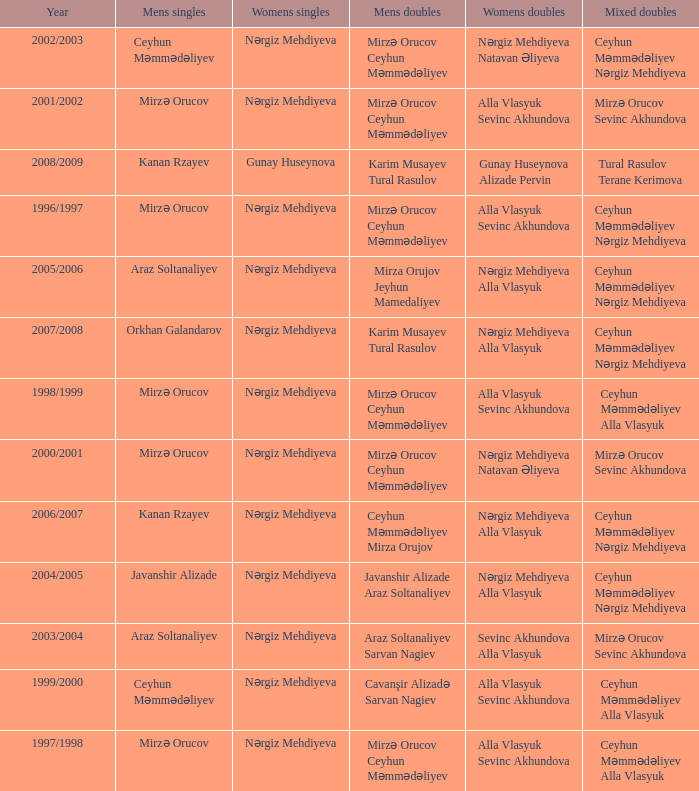Write the full table. {'header': ['Year', 'Mens singles', 'Womens singles', 'Mens doubles', 'Womens doubles', 'Mixed doubles'], 'rows': [['2002/2003', 'Ceyhun Məmmədəliyev', 'Nərgiz Mehdiyeva', 'Mirzə Orucov Ceyhun Məmmədəliyev', 'Nərgiz Mehdiyeva Natavan Əliyeva', 'Ceyhun Məmmədəliyev Nərgiz Mehdiyeva'], ['2001/2002', 'Mirzə Orucov', 'Nərgiz Mehdiyeva', 'Mirzə Orucov Ceyhun Məmmədəliyev', 'Alla Vlasyuk Sevinc Akhundova', 'Mirzə Orucov Sevinc Akhundova'], ['2008/2009', 'Kanan Rzayev', 'Gunay Huseynova', 'Karim Musayev Tural Rasulov', 'Gunay Huseynova Alizade Pervin', 'Tural Rasulov Terane Kerimova'], ['1996/1997', 'Mirzə Orucov', 'Nərgiz Mehdiyeva', 'Mirzə Orucov Ceyhun Məmmədəliyev', 'Alla Vlasyuk Sevinc Akhundova', 'Ceyhun Məmmədəliyev Nərgiz Mehdiyeva'], ['2005/2006', 'Araz Soltanaliyev', 'Nərgiz Mehdiyeva', 'Mirza Orujov Jeyhun Mamedaliyev', 'Nərgiz Mehdiyeva Alla Vlasyuk', 'Ceyhun Məmmədəliyev Nərgiz Mehdiyeva'], ['2007/2008', 'Orkhan Galandarov', 'Nərgiz Mehdiyeva', 'Karim Musayev Tural Rasulov', 'Nərgiz Mehdiyeva Alla Vlasyuk', 'Ceyhun Məmmədəliyev Nərgiz Mehdiyeva'], ['1998/1999', 'Mirzə Orucov', 'Nərgiz Mehdiyeva', 'Mirzə Orucov Ceyhun Məmmədəliyev', 'Alla Vlasyuk Sevinc Akhundova', 'Ceyhun Məmmədəliyev Alla Vlasyuk'], ['2000/2001', 'Mirzə Orucov', 'Nərgiz Mehdiyeva', 'Mirzə Orucov Ceyhun Məmmədəliyev', 'Nərgiz Mehdiyeva Natavan Əliyeva', 'Mirzə Orucov Sevinc Akhundova'], ['2006/2007', 'Kanan Rzayev', 'Nərgiz Mehdiyeva', 'Ceyhun Məmmədəliyev Mirza Orujov', 'Nərgiz Mehdiyeva Alla Vlasyuk', 'Ceyhun Məmmədəliyev Nərgiz Mehdiyeva'], ['2004/2005', 'Javanshir Alizade', 'Nərgiz Mehdiyeva', 'Javanshir Alizade Araz Soltanaliyev', 'Nərgiz Mehdiyeva Alla Vlasyuk', 'Ceyhun Məmmədəliyev Nərgiz Mehdiyeva'], ['2003/2004', 'Araz Soltanaliyev', 'Nərgiz Mehdiyeva', 'Araz Soltanaliyev Sarvan Nagiev', 'Sevinc Akhundova Alla Vlasyuk', 'Mirzə Orucov Sevinc Akhundova'], ['1999/2000', 'Ceyhun Məmmədəliyev', 'Nərgiz Mehdiyeva', 'Cavanşir Alizadə Sarvan Nagiev', 'Alla Vlasyuk Sevinc Akhundova', 'Ceyhun Məmmədəliyev Alla Vlasyuk'], ['1997/1998', 'Mirzə Orucov', 'Nərgiz Mehdiyeva', 'Mirzə Orucov Ceyhun Məmmədəliyev', 'Alla Vlasyuk Sevinc Akhundova', 'Ceyhun Məmmədəliyev Alla Vlasyuk']]} Who were all womens doubles for the year 2000/2001? Nərgiz Mehdiyeva Natavan Əliyeva. 